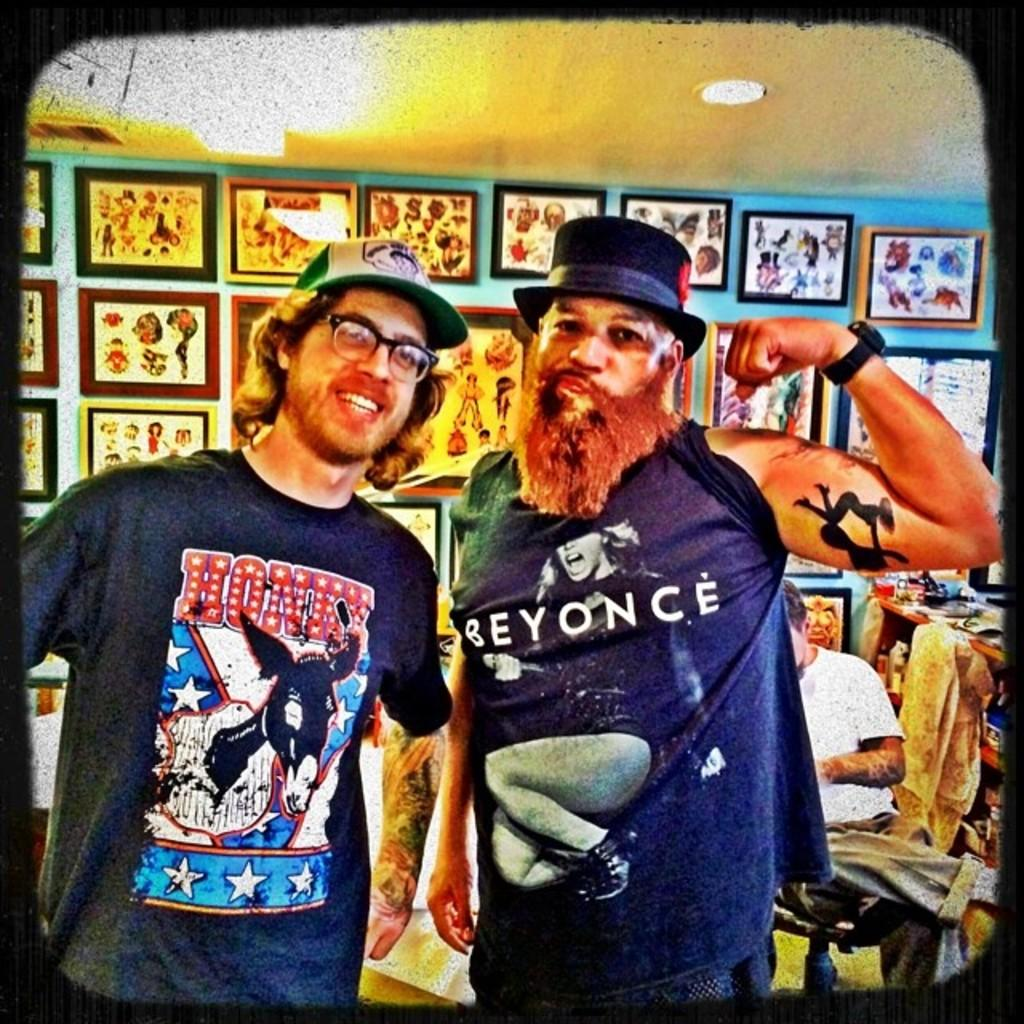How many people are in the image? There are two men in the image. What are the men wearing on their heads? The men are wearing caps. Where are the men standing? The men are standing on the floor. What can be seen on the wall in the background? There are frames on the wall in the background. Can you describe the person in the background? There is a person sitting on a chair in the background. What type of gun is the person holding in the image? There is no person holding a gun in the image; the two men are wearing caps and standing on the floor. What place is depicted in the image? The image does not show a specific place; it only shows two men, their clothing, and the background. 